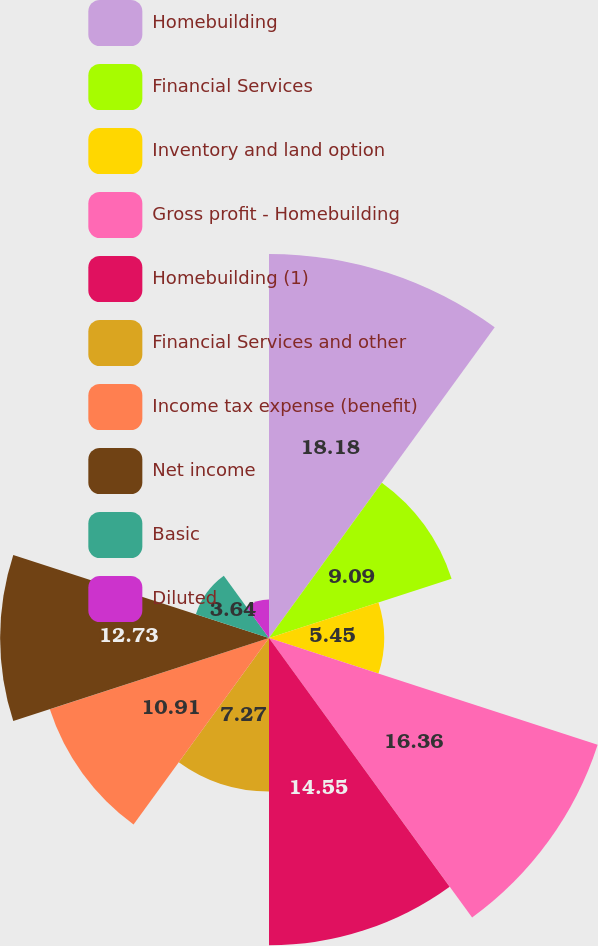<chart> <loc_0><loc_0><loc_500><loc_500><pie_chart><fcel>Homebuilding<fcel>Financial Services<fcel>Inventory and land option<fcel>Gross profit - Homebuilding<fcel>Homebuilding (1)<fcel>Financial Services and other<fcel>Income tax expense (benefit)<fcel>Net income<fcel>Basic<fcel>Diluted<nl><fcel>18.18%<fcel>9.09%<fcel>5.45%<fcel>16.36%<fcel>14.55%<fcel>7.27%<fcel>10.91%<fcel>12.73%<fcel>3.64%<fcel>1.82%<nl></chart> 